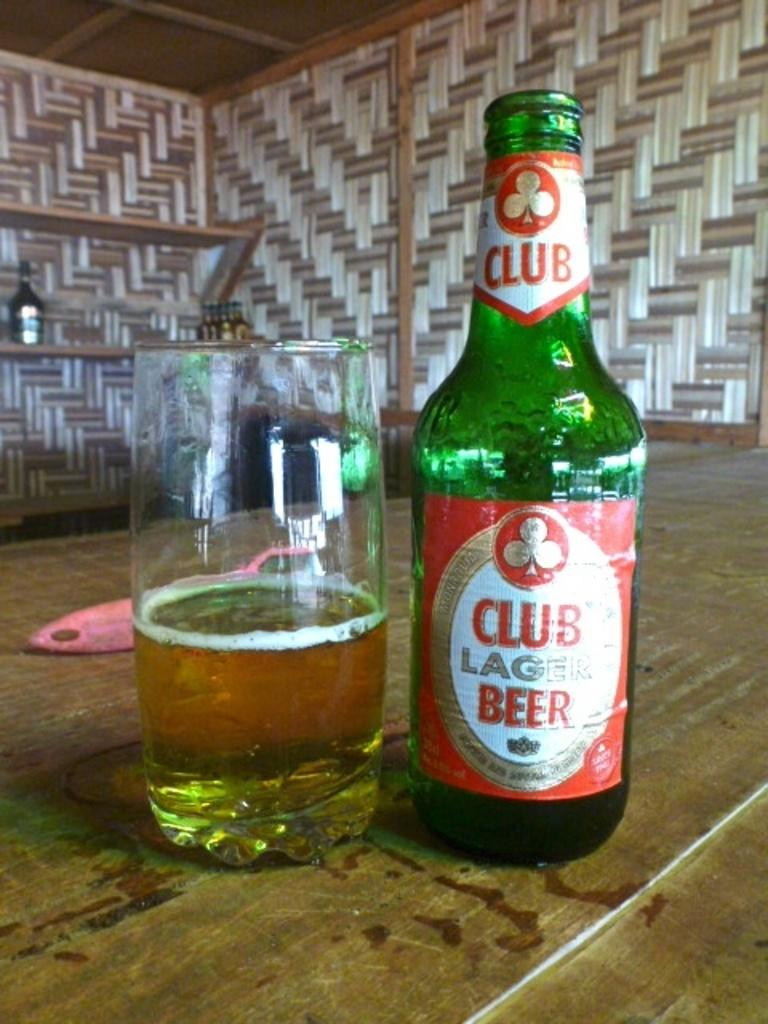What is in the glass that is visible in the image? There is a glass of wine in the image. What other wine-related objects can be seen in the image? There is a wine bottle and a wine opener visible in the image. Where are these objects located? All these objects are on a table. What can be seen in the background of the image? There is a bottle on a stand and a wall in the background of the image. What type of music is the band playing in the background of the image? There is no band present in the image, so it is not possible to determine what type of music might be playing. 